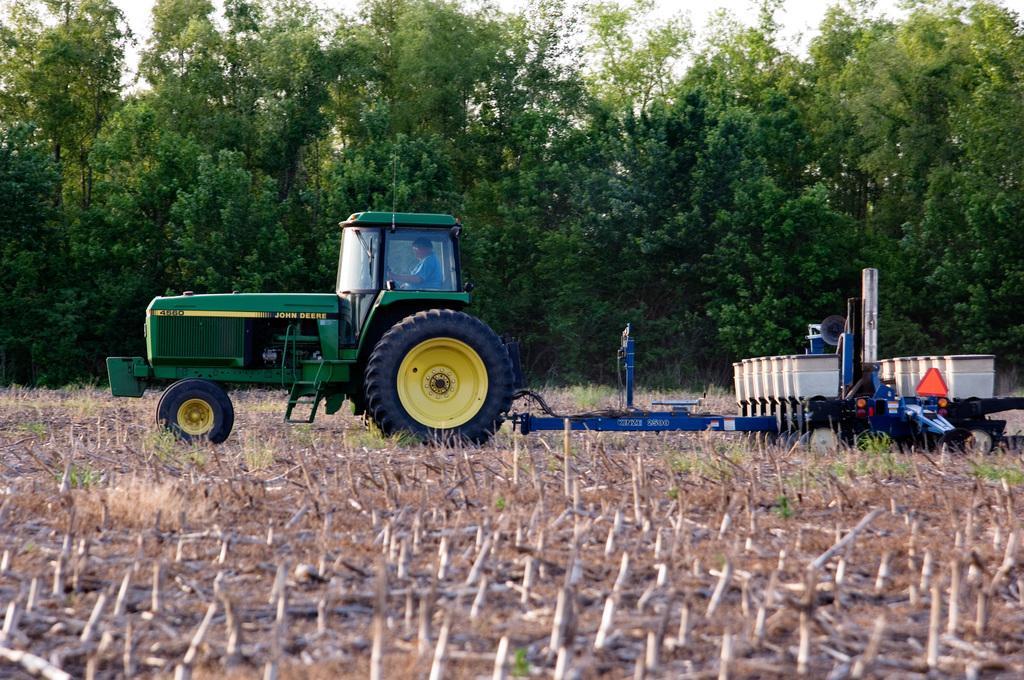How would you summarize this image in a sentence or two? In this picture we can see a person inside a tractor on the ground, grass and some objects and in the background we can see trees. 